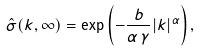Convert formula to latex. <formula><loc_0><loc_0><loc_500><loc_500>\hat { \sigma } ( k , \infty ) = \exp \left ( - \frac { b } { \alpha \, \gamma } | k | ^ { \alpha } \right ) ,</formula> 